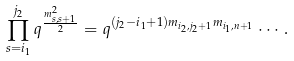Convert formula to latex. <formula><loc_0><loc_0><loc_500><loc_500>\prod _ { s = i _ { 1 } } ^ { j _ { 2 } } q ^ { \frac { m ^ { 2 } _ { s , s + 1 } } { 2 } } = q ^ { ( j _ { 2 } - i _ { 1 } + 1 ) m _ { i _ { 2 } , j _ { 2 } + 1 } m _ { i _ { 1 } , n + 1 } } \cdots .</formula> 